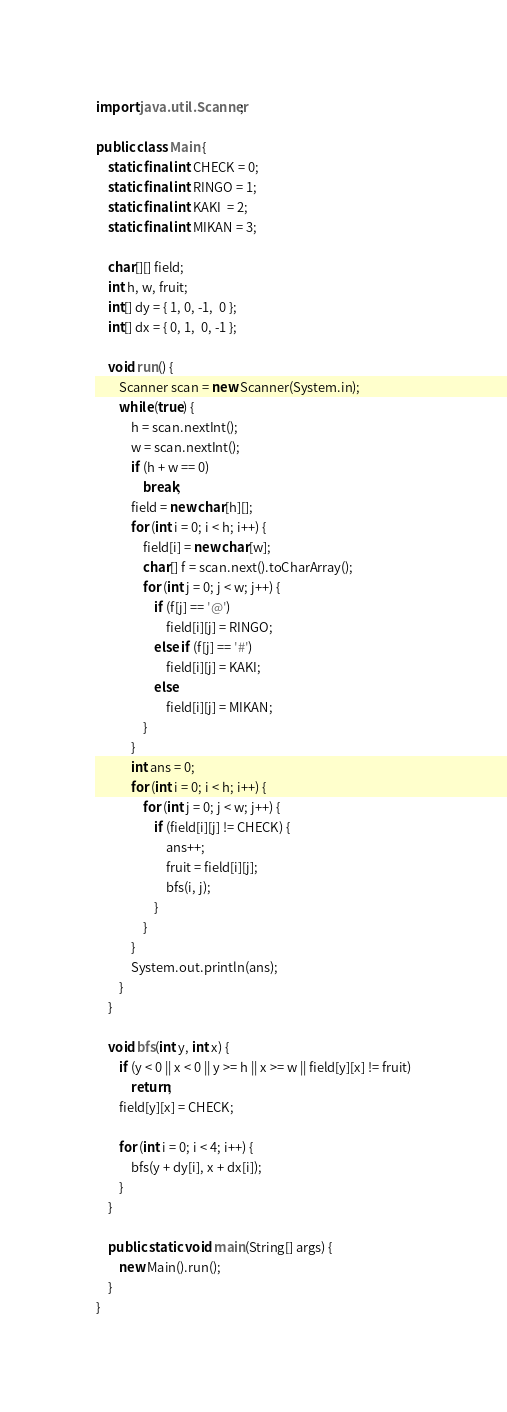Convert code to text. <code><loc_0><loc_0><loc_500><loc_500><_Java_>import java.util.Scanner;

public class Main {
	static final int CHECK = 0;
	static final int RINGO = 1;
	static final int KAKI  = 2;
	static final int MIKAN = 3;
	
	char[][] field;
	int h, w, fruit;
	int[] dy = { 1, 0, -1,  0 };
	int[] dx = { 0, 1,  0, -1 };

	void run() {
		Scanner scan = new Scanner(System.in);
		while (true) {
			h = scan.nextInt();
			w = scan.nextInt();
			if (h + w == 0)
				break;
			field = new char[h][];
			for (int i = 0; i < h; i++) {
				field[i] = new char[w];
				char[] f = scan.next().toCharArray();
				for (int j = 0; j < w; j++) {
					if (f[j] == '@')
						field[i][j] = RINGO;
					else if (f[j] == '#')
						field[i][j] = KAKI;
					else
						field[i][j] = MIKAN;
				}
			}
			int ans = 0;
			for (int i = 0; i < h; i++) {
				for (int j = 0; j < w; j++) {
					if (field[i][j] != CHECK) {
						ans++;
						fruit = field[i][j];
						bfs(i, j);
					}
				}
			}
			System.out.println(ans);
		}
	}

	void bfs(int y, int x) {
		if (y < 0 || x < 0 || y >= h || x >= w || field[y][x] != fruit)
			return;
		field[y][x] = CHECK;

		for (int i = 0; i < 4; i++) {
			bfs(y + dy[i], x + dx[i]);
		}
	}

	public static void main(String[] args) {
		new Main().run();
	}
}</code> 